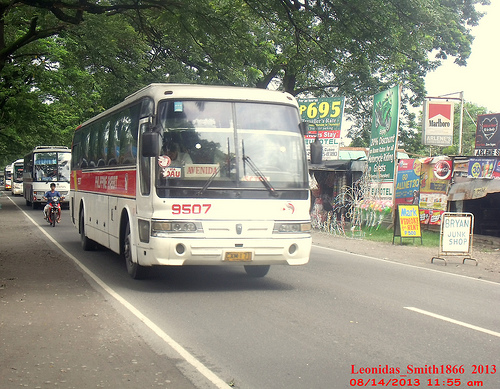Please provide a short description for this region: [0.72, 0.29, 0.8, 0.55]. A green road sign on the side of the road with various advertisements and brand logos. 